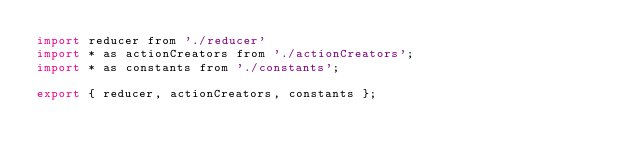Convert code to text. <code><loc_0><loc_0><loc_500><loc_500><_JavaScript_>import reducer from './reducer'
import * as actionCreators from './actionCreators';
import * as constants from './constants';

export { reducer, actionCreators, constants };</code> 